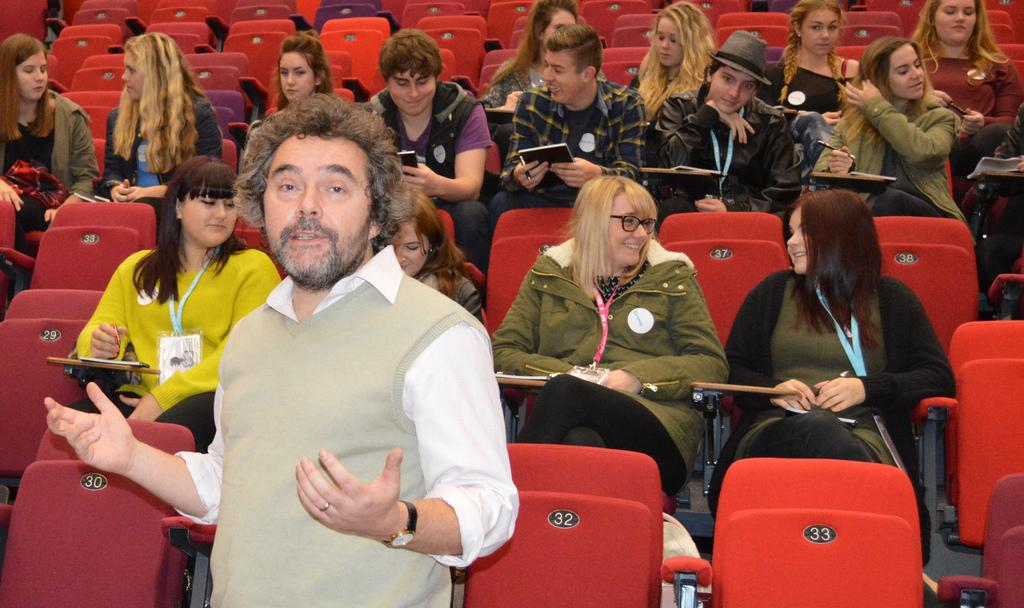What is happening in the image? There is a group of people in the image, and they are sitting on chairs. Is there anyone standing in the image? Yes, there is one man standing in the center of the group. What type of zephyr can be seen blowing through the group in the image? There is no zephyr present in the image; it is a group of people sitting on chairs and standing. How many times does the man in the center of the group twist his body in the image? There is no indication in the image that the man is twisting his body; he is simply standing in the center of the group. 